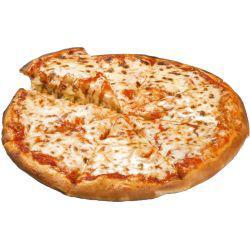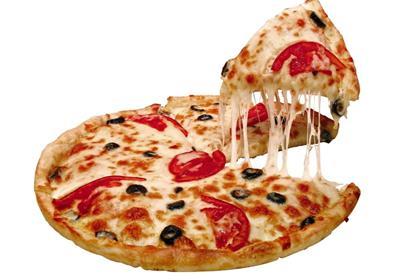The first image is the image on the left, the second image is the image on the right. Considering the images on both sides, is "A slice is being taken out of a pizza in the right image, with the cheese oozing down." valid? Answer yes or no. Yes. The first image is the image on the left, the second image is the image on the right. Evaluate the accuracy of this statement regarding the images: "A slice is being lifted off a pizza.". Is it true? Answer yes or no. Yes. 